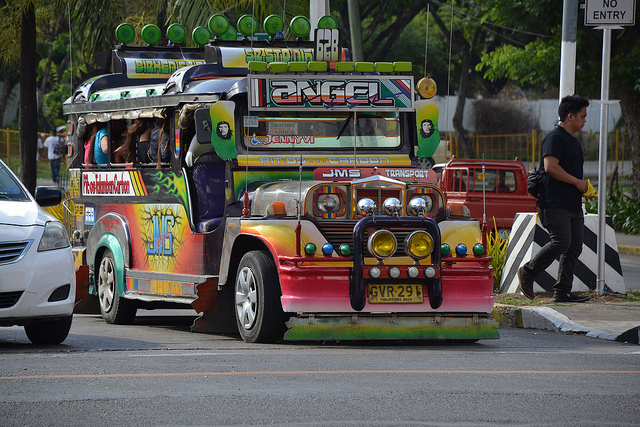Please transcribe the text information in this image. aNGEL 628 JMS TRANSPORT ENTRY NO JENNYVi 29 GVR J6 